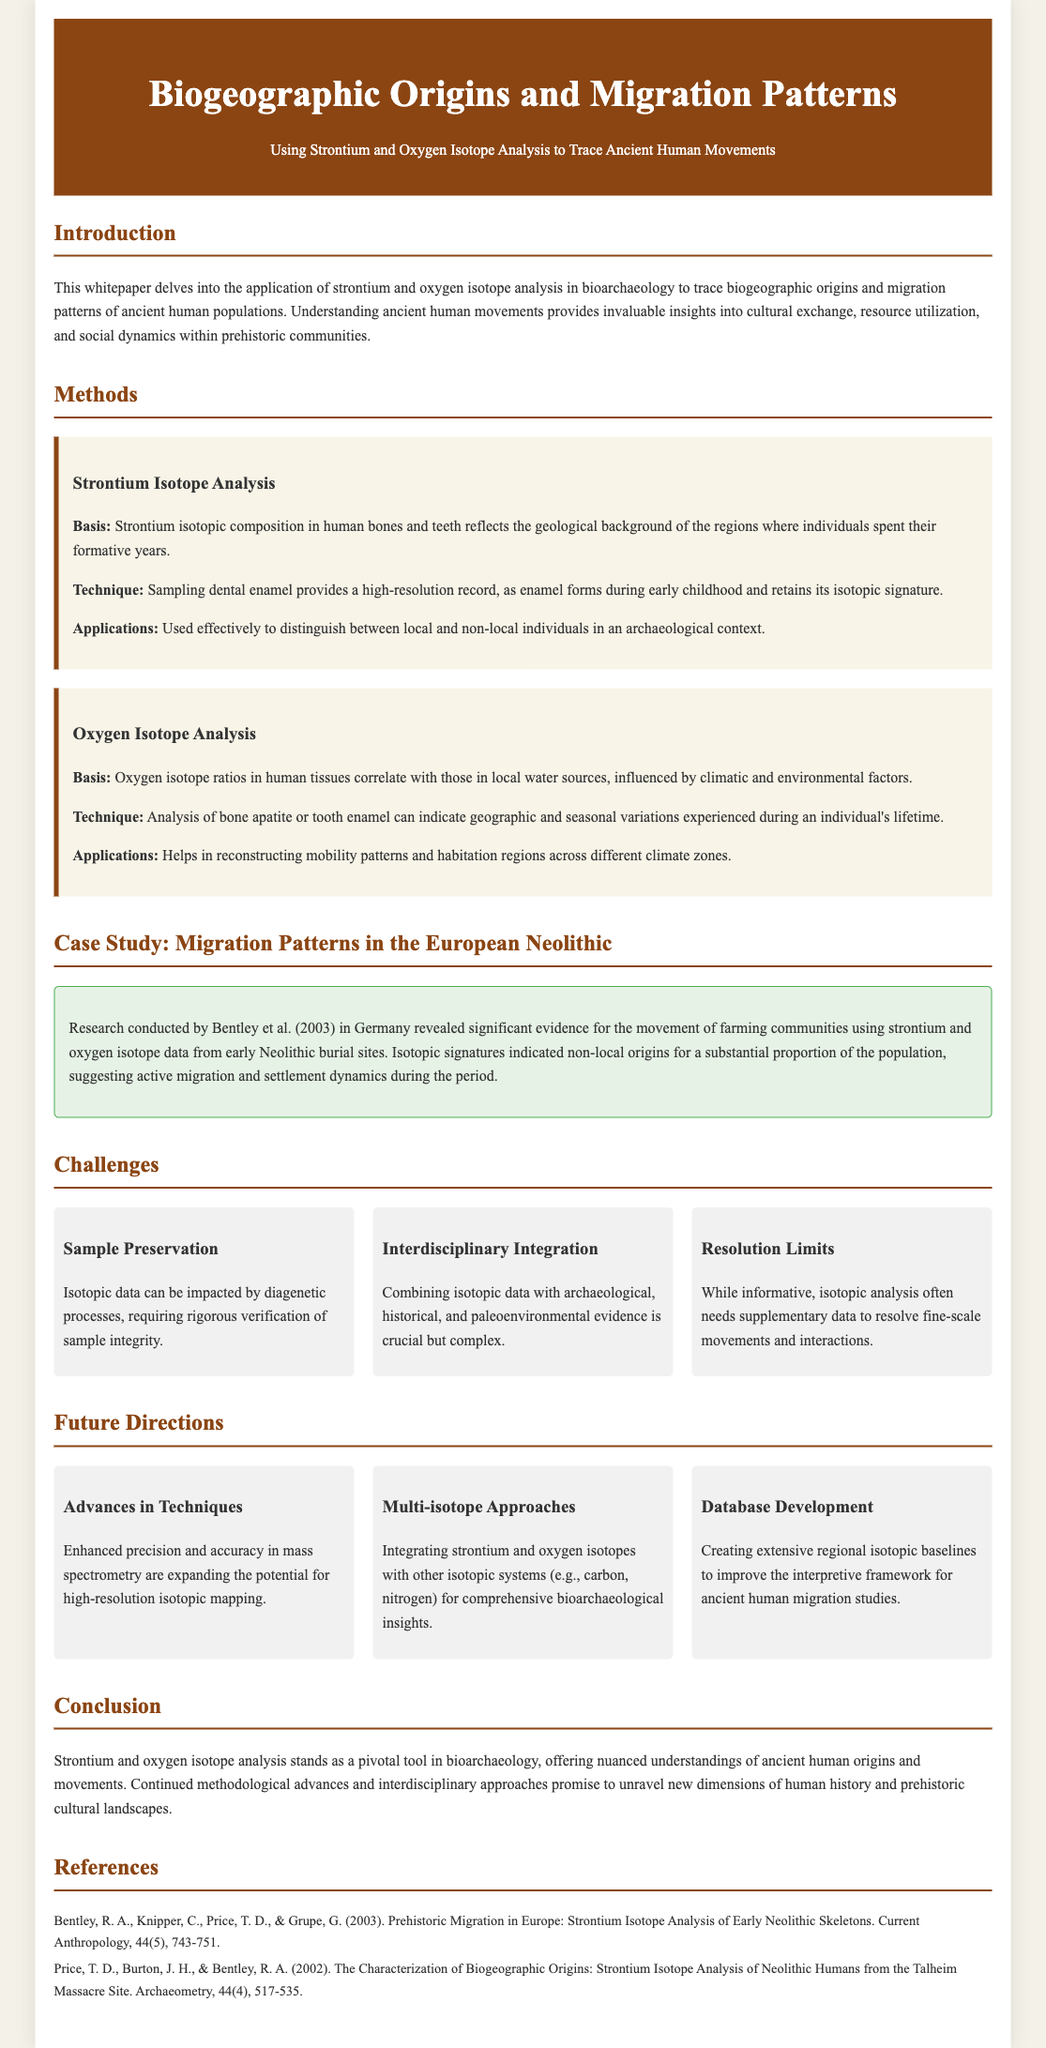What is the title of the whitepaper? The title is explicitly stated in the document's header section, focusing on biogeographic origins and migration patterns.
Answer: Biogeographic Origins and Migration Patterns What year was the research conducted by Bentley et al.? The year of the research is mentioned in the case study section of the document, which cites the work of Bentley and colleagues.
Answer: 2003 Which isotopes are primarily analyzed in this research? The methods section specifies the two types of isotopes used in the investigations to trace human movements.
Answer: Strontium and Oxygen What is one application of strontium isotope analysis? The methods section highlights how strontium isotopic data is effectively used in archaeological contexts to distinguish certain individuals.
Answer: Distinguish between local and non-local individuals What challenge is related to sample preservation? This challenge is outlined in the challenges section, emphasizing the impact of diagenetic processes on isotopic data.
Answer: Diagenetic processes What is one future direction mentioned for the research? The future directions section provides insights into enhanced techniques that could improve the accuracy of isotopic mapping.
Answer: Advances in Techniques Who are the authors of the reference cited in the case study? The reference section lists the authors of the research paper that is the focus of the case study, indicating their contributions.
Answer: Bentley, R. A., Knipper, C., Price, T. D., & Grupe, G What does oxygen isotope analysis correlate with? The basis of oxygen isotope analysis referenced in the methods section relates this analysis to a particular environmental factor.
Answer: Local water sources 